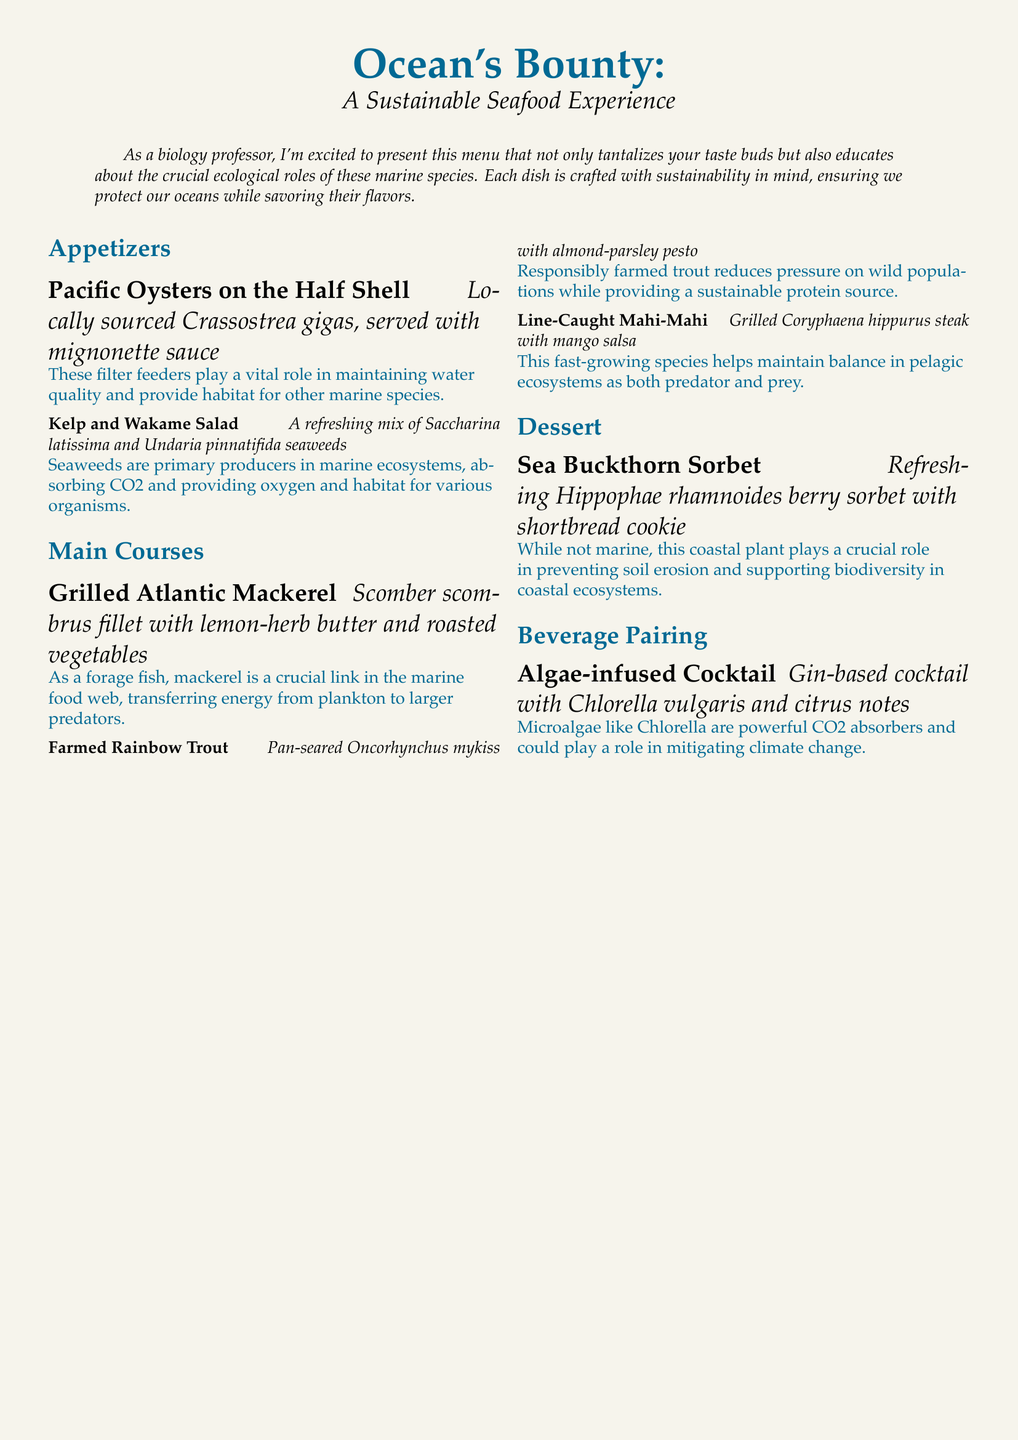What species of oyster is served? The document lists "Pacific Oysters" and specifies the species as "Crassostrea gigas."
Answer: Crassostrea gigas What type of seaweed is used in the salad? The menu mentions "Saccharina latissima" and "Undaria pinnatifida" as the seaweeds in the salad.
Answer: Saccharina latissima and Undaria pinnatifida What is the ecological role of Pacific Oysters? It states that Pacific Oysters are filter feeders that help maintain water quality and provide habitat for other marine species.
Answer: Maintain water quality What is the main protein source in the Grilled Atlantic Mackerel dish? The dish features "Scomber scombrus," which is the scientific name for Atlantic Mackerel.
Answer: Scomber scombrus How does responsible farming of Rainbow Trout benefit marine ecosystems? The text indicates that responsibly farmed trout reduces pressure on wild populations.
Answer: Reduces pressure on wild populations What type of cocktail is paired with the meal? The menu specifies an "Algae-infused Cocktail" as a beverage pairing.
Answer: Algae-infused Cocktail What is the primary ecological function of seaweeds mentioned in the Kelp and Wakame Salad? The document notes that seaweeds are primary producers absorbing CO2 and providing oxygen.
Answer: Primary producers What dessert is included in the menu? The document lists "Sea Buckthorn Sorbet" as the dessert option.
Answer: Sea Buckthorn Sorbet 